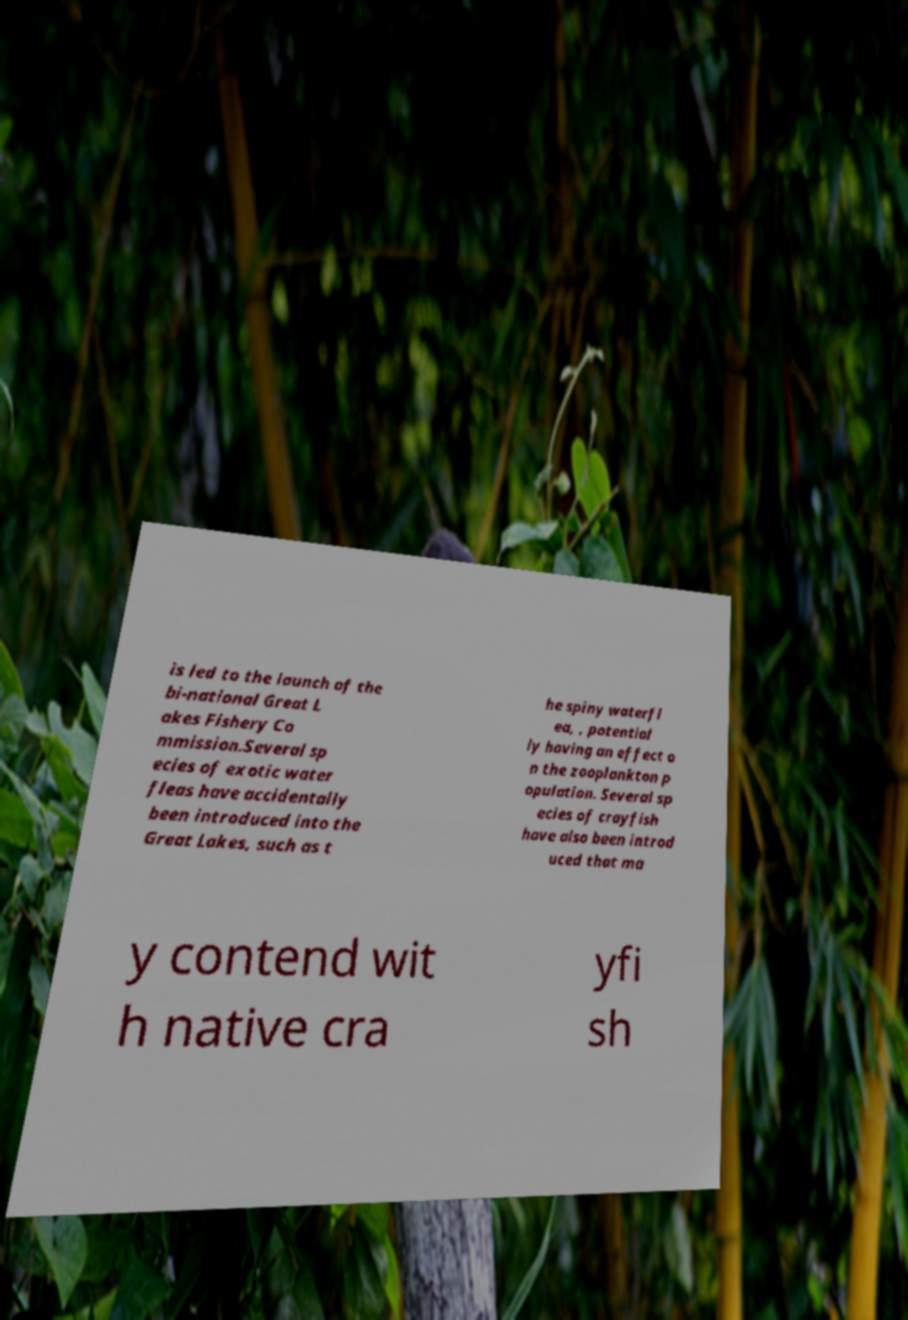Please identify and transcribe the text found in this image. is led to the launch of the bi-national Great L akes Fishery Co mmission.Several sp ecies of exotic water fleas have accidentally been introduced into the Great Lakes, such as t he spiny waterfl ea, , potential ly having an effect o n the zooplankton p opulation. Several sp ecies of crayfish have also been introd uced that ma y contend wit h native cra yfi sh 